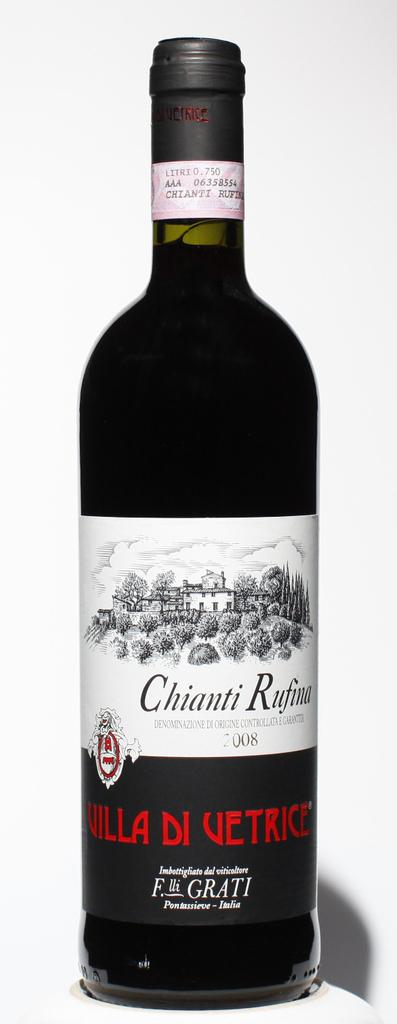<image>
Share a concise interpretation of the image provided. a black bottle of wine labeled villa di vetrice 